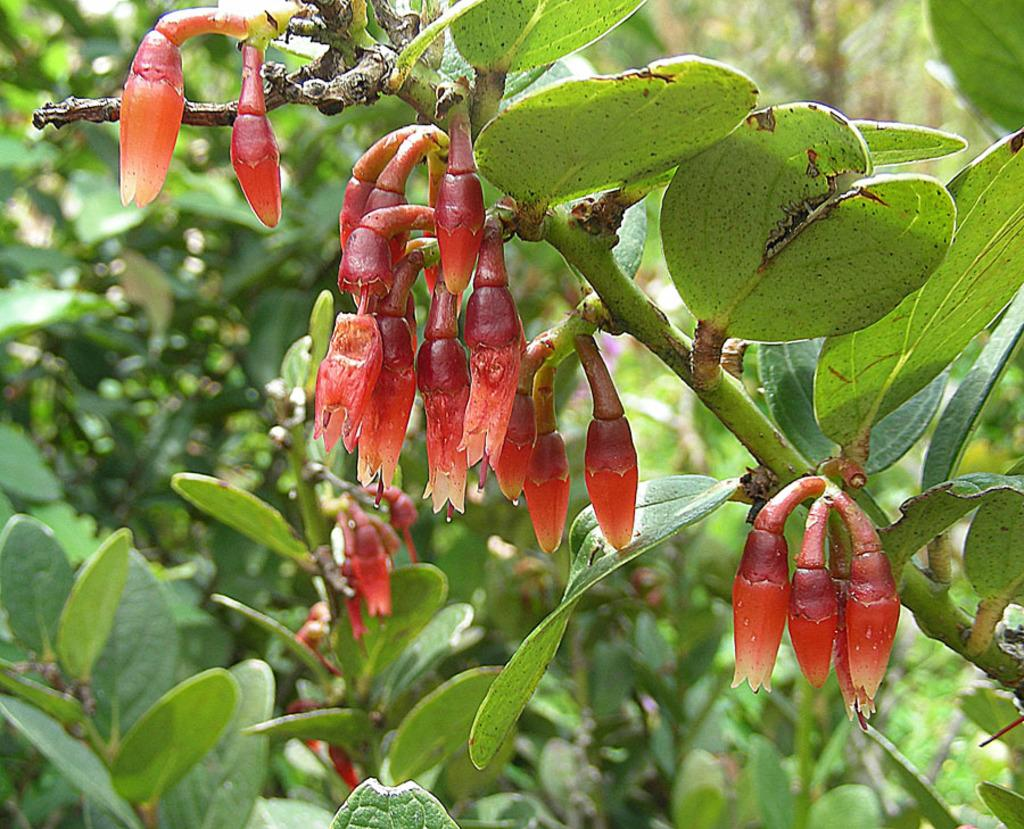What is the main subject of the picture? The main subject of the picture is a tree. What can be observed about the tree in the image? The tree has flowers and flower buds. How would you describe the background of the image? The background of the image is blurred. What statement is being made by the watch in the image? There is no watch present in the image, so no statement can be made by a watch. 